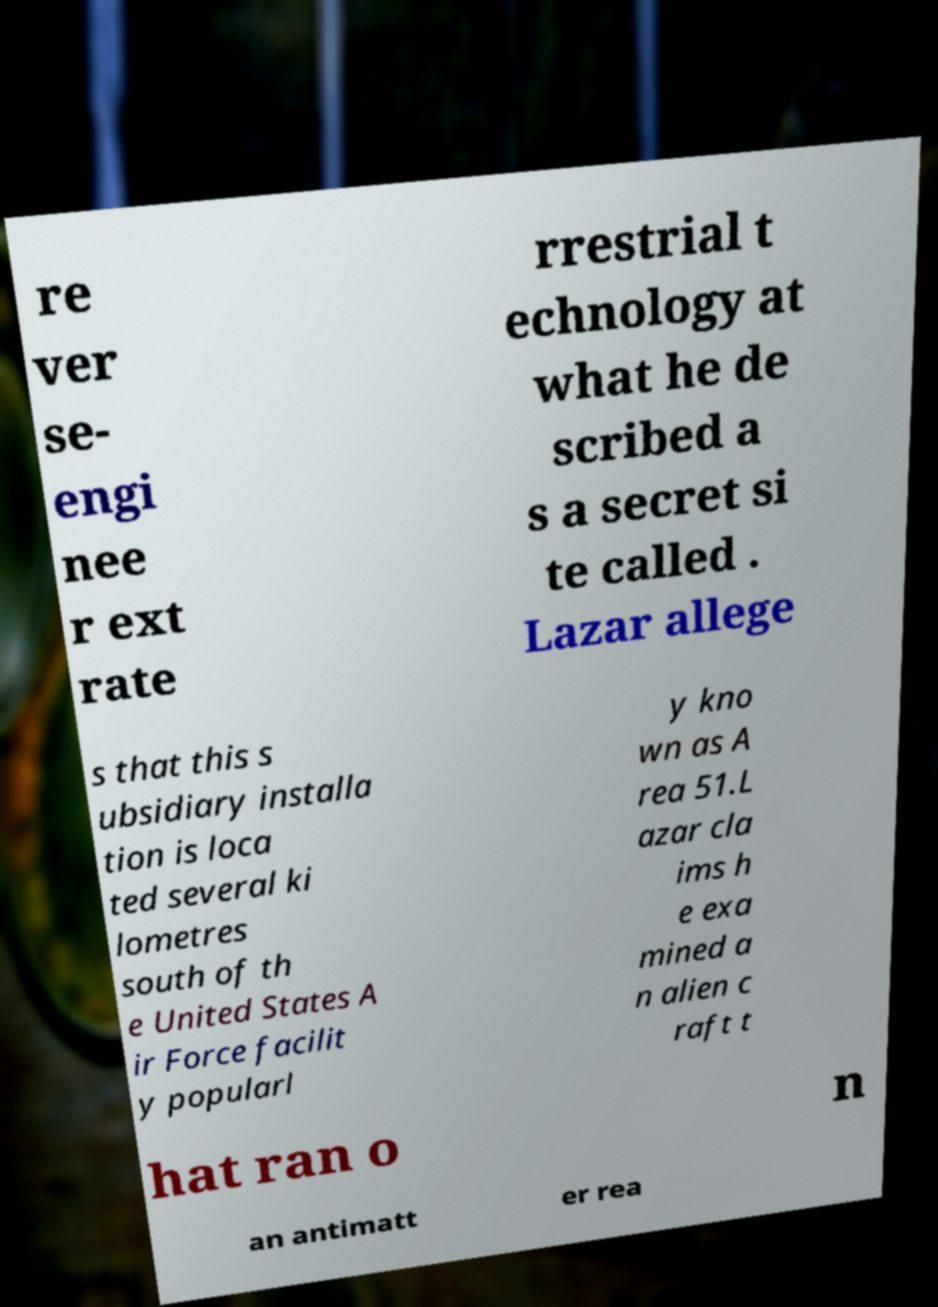What messages or text are displayed in this image? I need them in a readable, typed format. re ver se- engi nee r ext rate rrestrial t echnology at what he de scribed a s a secret si te called . Lazar allege s that this s ubsidiary installa tion is loca ted several ki lometres south of th e United States A ir Force facilit y popularl y kno wn as A rea 51.L azar cla ims h e exa mined a n alien c raft t hat ran o n an antimatt er rea 